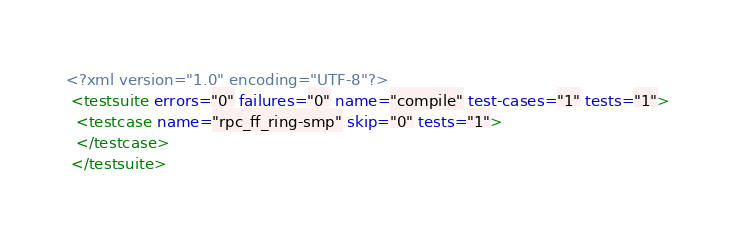<code> <loc_0><loc_0><loc_500><loc_500><_XML_><?xml version="1.0" encoding="UTF-8"?>
 <testsuite errors="0" failures="0" name="compile" test-cases="1" tests="1">
  <testcase name="rpc_ff_ring-smp" skip="0" tests="1">
  </testcase>
 </testsuite>
</code> 